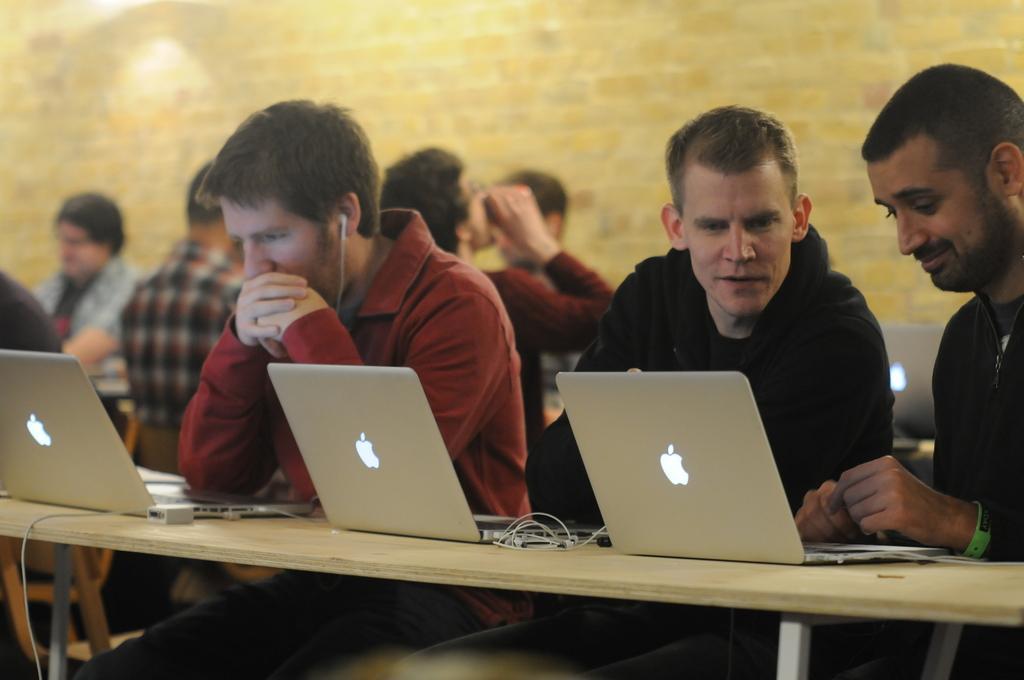How would you summarize this image in a sentence or two? In this picture we can see group of peoples sitting on chairs and in front of them we have table and on table we can see laptop, wires, chargers and in background we can see wall. 